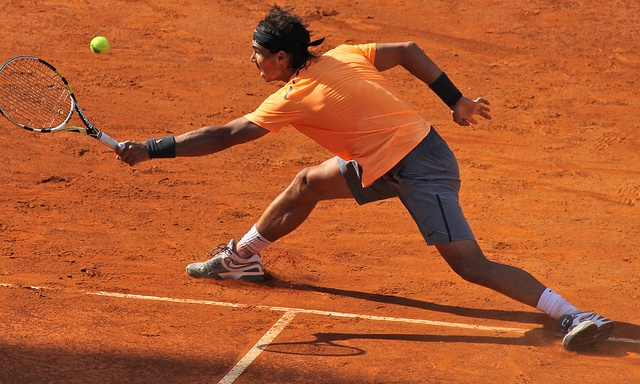Describe the objects in this image and their specific colors. I can see people in red, maroon, black, and brown tones, tennis racket in red and brown tones, and sports ball in red, olive, and khaki tones in this image. 